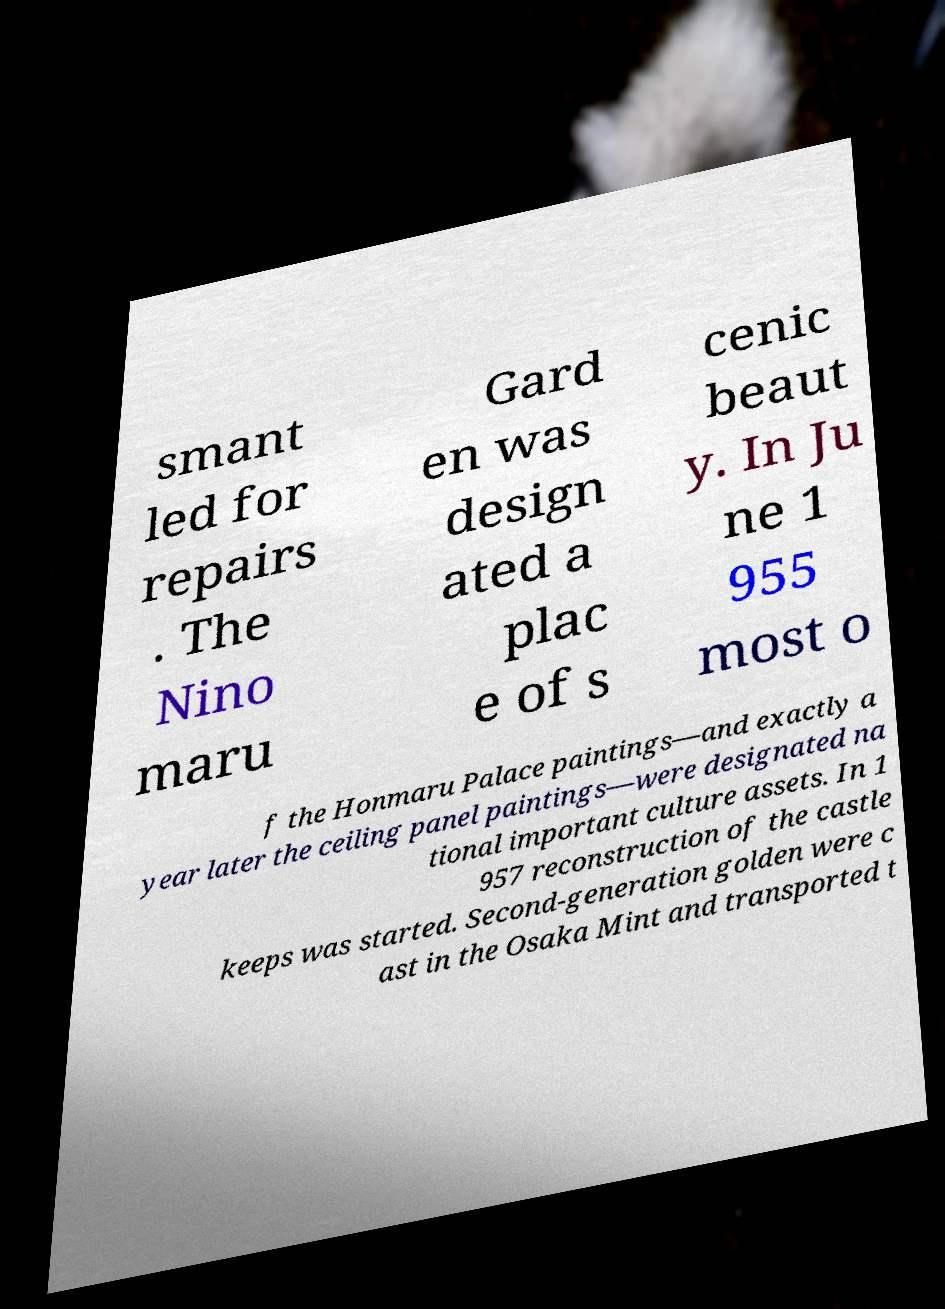For documentation purposes, I need the text within this image transcribed. Could you provide that? smant led for repairs . The Nino maru Gard en was design ated a plac e of s cenic beaut y. In Ju ne 1 955 most o f the Honmaru Palace paintings—and exactly a year later the ceiling panel paintings—were designated na tional important culture assets. In 1 957 reconstruction of the castle keeps was started. Second-generation golden were c ast in the Osaka Mint and transported t 